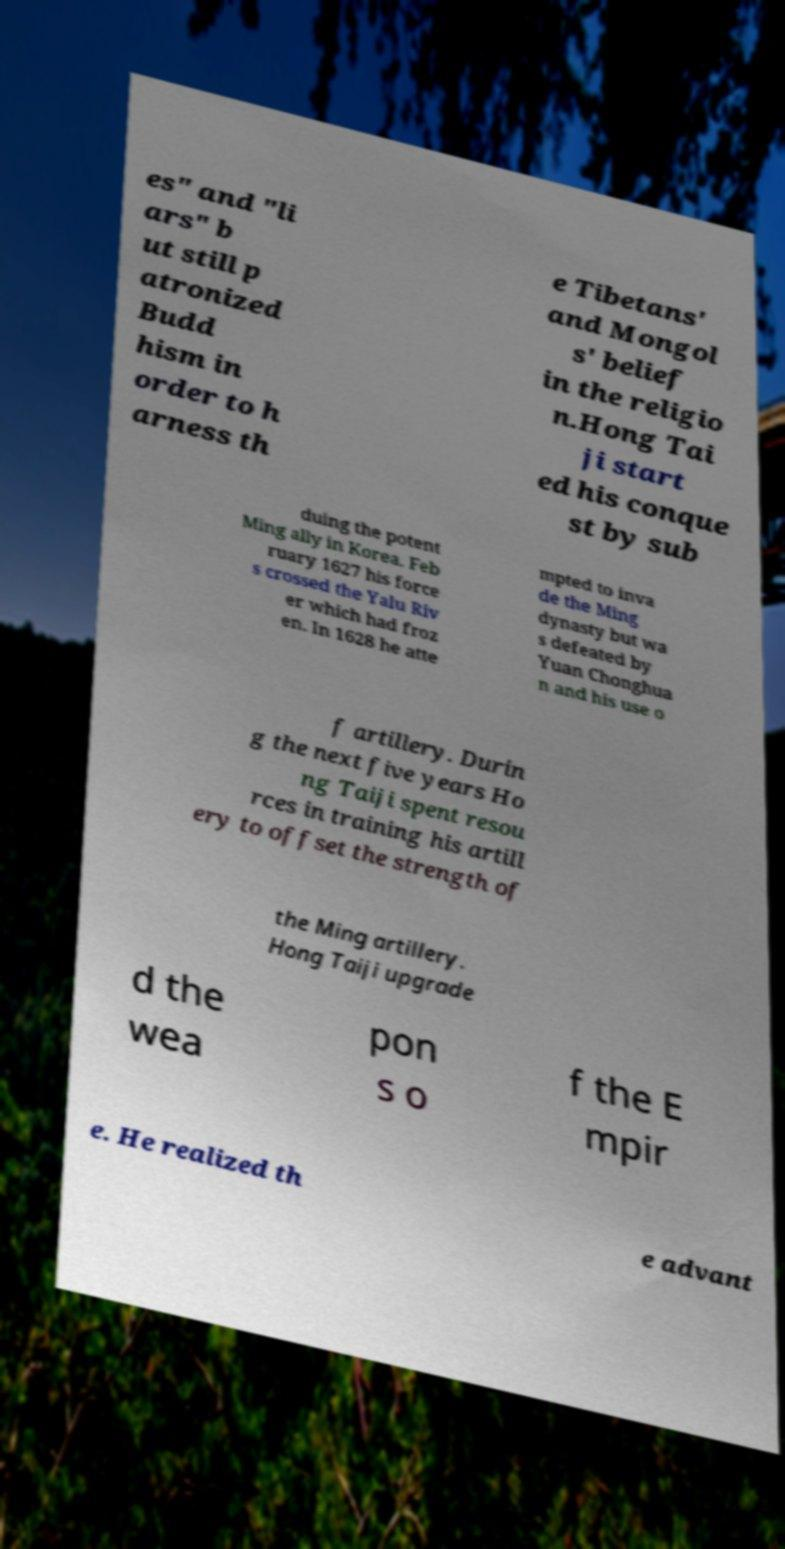I need the written content from this picture converted into text. Can you do that? es" and "li ars" b ut still p atronized Budd hism in order to h arness th e Tibetans' and Mongol s' belief in the religio n.Hong Tai ji start ed his conque st by sub duing the potent Ming ally in Korea. Feb ruary 1627 his force s crossed the Yalu Riv er which had froz en. In 1628 he atte mpted to inva de the Ming dynasty but wa s defeated by Yuan Chonghua n and his use o f artillery. Durin g the next five years Ho ng Taiji spent resou rces in training his artill ery to offset the strength of the Ming artillery. Hong Taiji upgrade d the wea pon s o f the E mpir e. He realized th e advant 